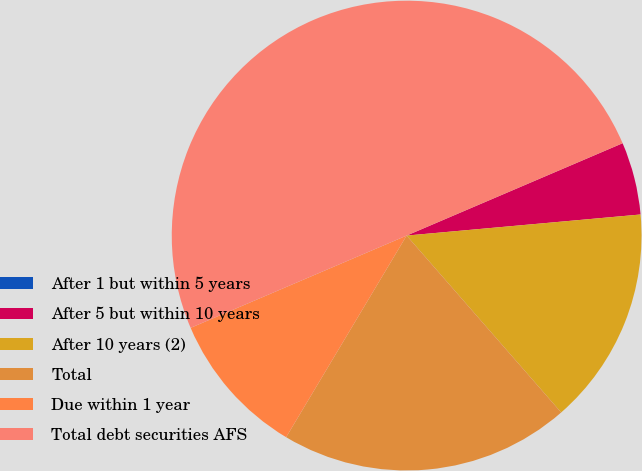Convert chart to OTSL. <chart><loc_0><loc_0><loc_500><loc_500><pie_chart><fcel>After 1 but within 5 years<fcel>After 5 but within 10 years<fcel>After 10 years (2)<fcel>Total<fcel>Due within 1 year<fcel>Total debt securities AFS<nl><fcel>0.0%<fcel>5.0%<fcel>15.0%<fcel>20.0%<fcel>10.0%<fcel>49.99%<nl></chart> 